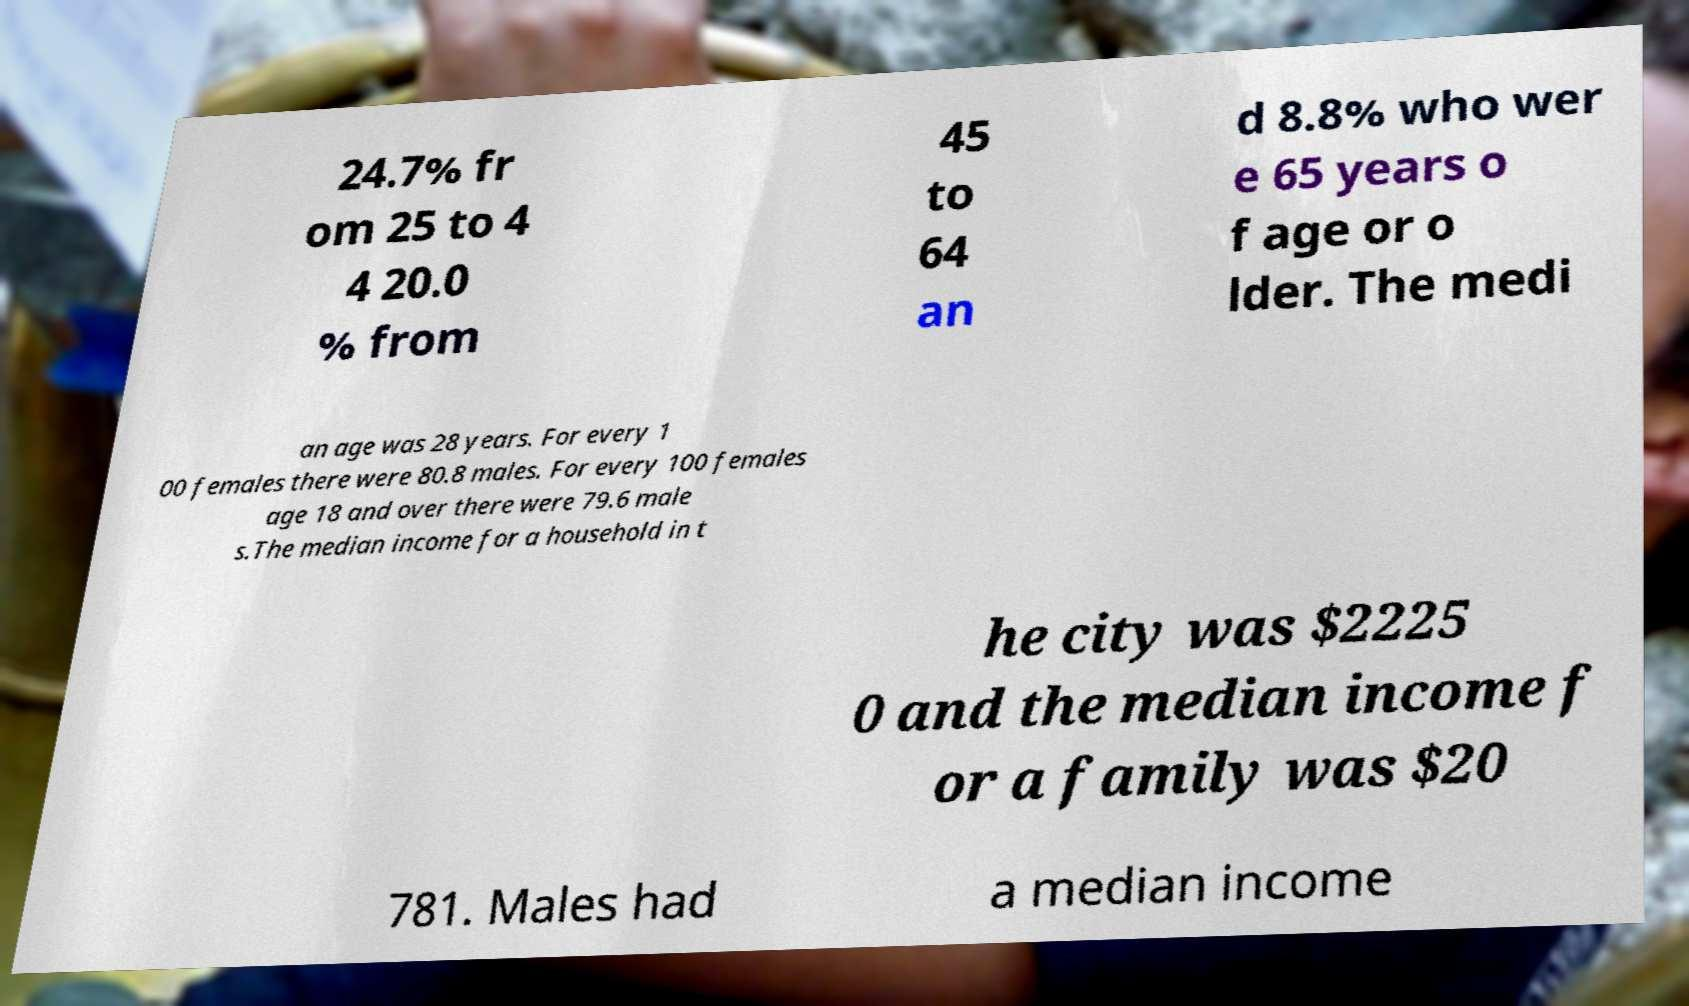Please read and relay the text visible in this image. What does it say? 24.7% fr om 25 to 4 4 20.0 % from 45 to 64 an d 8.8% who wer e 65 years o f age or o lder. The medi an age was 28 years. For every 1 00 females there were 80.8 males. For every 100 females age 18 and over there were 79.6 male s.The median income for a household in t he city was $2225 0 and the median income f or a family was $20 781. Males had a median income 